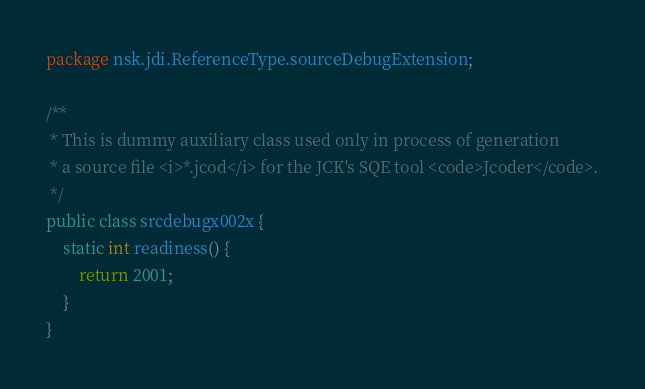<code> <loc_0><loc_0><loc_500><loc_500><_Java_>package nsk.jdi.ReferenceType.sourceDebugExtension;

/**
 * This is dummy auxiliary class used only in process of generation
 * a source file <i>*.jcod</i> for the JCK's SQE tool <code>Jcoder</code>.
 */
public class srcdebugx002x {
    static int readiness() {
        return 2001;
    }
}
</code> 